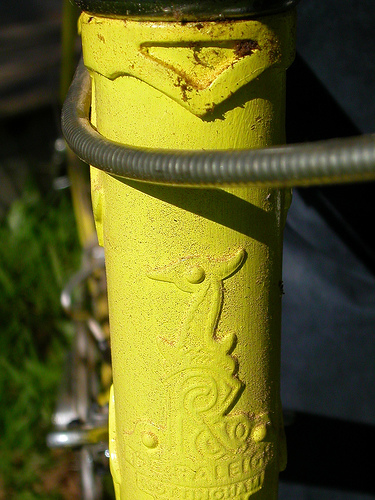<image>
Is the hose behind the pipe? No. The hose is not behind the pipe. From this viewpoint, the hose appears to be positioned elsewhere in the scene. 